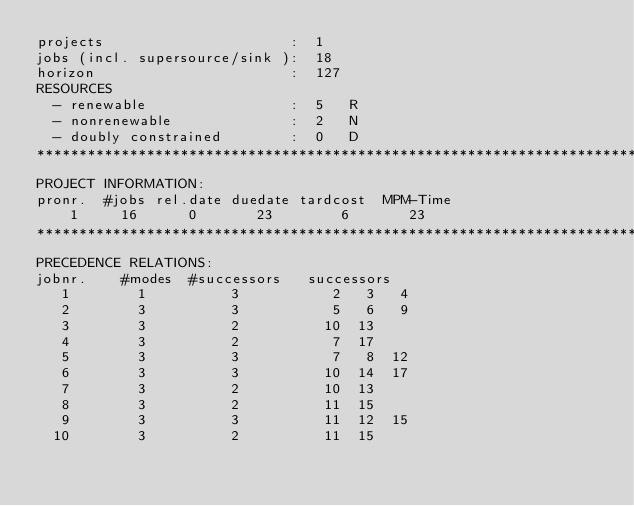Convert code to text. <code><loc_0><loc_0><loc_500><loc_500><_ObjectiveC_>projects                      :  1
jobs (incl. supersource/sink ):  18
horizon                       :  127
RESOURCES
  - renewable                 :  5   R
  - nonrenewable              :  2   N
  - doubly constrained        :  0   D
************************************************************************
PROJECT INFORMATION:
pronr.  #jobs rel.date duedate tardcost  MPM-Time
    1     16      0       23        6       23
************************************************************************
PRECEDENCE RELATIONS:
jobnr.    #modes  #successors   successors
   1        1          3           2   3   4
   2        3          3           5   6   9
   3        3          2          10  13
   4        3          2           7  17
   5        3          3           7   8  12
   6        3          3          10  14  17
   7        3          2          10  13
   8        3          2          11  15
   9        3          3          11  12  15
  10        3          2          11  15</code> 